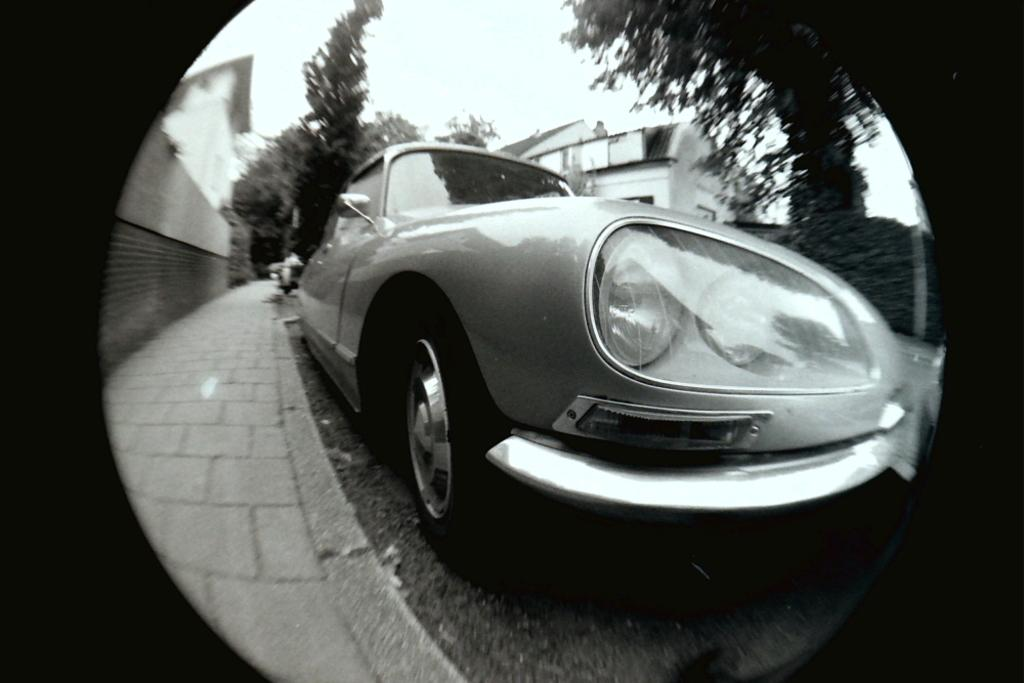What is the color scheme of the image? The image is black and white. What can be seen on the road in the image? There is a car on the road in the image. What type of natural scenery is visible in the background of the image? There are trees in the background of the image. What type of man-made structures can be seen in the background of the image? There are buildings in the background of the image. What part of the natural environment is visible in the background of the image? The sky is visible in the background of the image. What type of farming equipment can be seen in the image? There is no farming equipment present in the image; it is a black and white image featuring a car on the road with trees, buildings, and the sky in the background. 